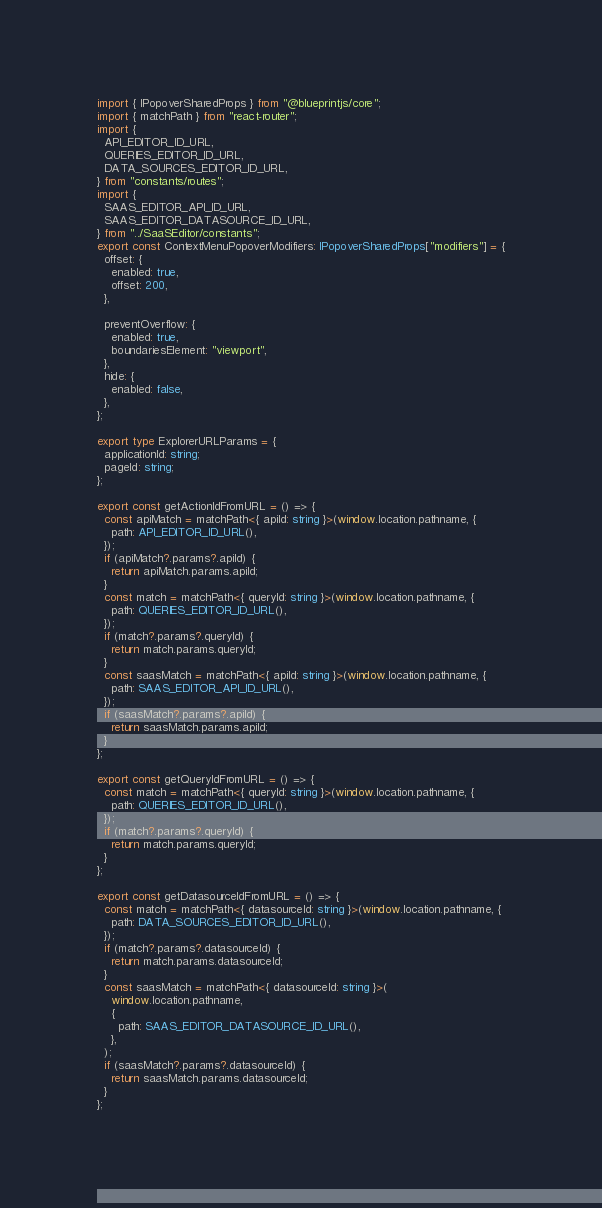Convert code to text. <code><loc_0><loc_0><loc_500><loc_500><_TypeScript_>import { IPopoverSharedProps } from "@blueprintjs/core";
import { matchPath } from "react-router";
import {
  API_EDITOR_ID_URL,
  QUERIES_EDITOR_ID_URL,
  DATA_SOURCES_EDITOR_ID_URL,
} from "constants/routes";
import {
  SAAS_EDITOR_API_ID_URL,
  SAAS_EDITOR_DATASOURCE_ID_URL,
} from "../SaaSEditor/constants";
export const ContextMenuPopoverModifiers: IPopoverSharedProps["modifiers"] = {
  offset: {
    enabled: true,
    offset: 200,
  },

  preventOverflow: {
    enabled: true,
    boundariesElement: "viewport",
  },
  hide: {
    enabled: false,
  },
};

export type ExplorerURLParams = {
  applicationId: string;
  pageId: string;
};

export const getActionIdFromURL = () => {
  const apiMatch = matchPath<{ apiId: string }>(window.location.pathname, {
    path: API_EDITOR_ID_URL(),
  });
  if (apiMatch?.params?.apiId) {
    return apiMatch.params.apiId;
  }
  const match = matchPath<{ queryId: string }>(window.location.pathname, {
    path: QUERIES_EDITOR_ID_URL(),
  });
  if (match?.params?.queryId) {
    return match.params.queryId;
  }
  const saasMatch = matchPath<{ apiId: string }>(window.location.pathname, {
    path: SAAS_EDITOR_API_ID_URL(),
  });
  if (saasMatch?.params?.apiId) {
    return saasMatch.params.apiId;
  }
};

export const getQueryIdFromURL = () => {
  const match = matchPath<{ queryId: string }>(window.location.pathname, {
    path: QUERIES_EDITOR_ID_URL(),
  });
  if (match?.params?.queryId) {
    return match.params.queryId;
  }
};

export const getDatasourceIdFromURL = () => {
  const match = matchPath<{ datasourceId: string }>(window.location.pathname, {
    path: DATA_SOURCES_EDITOR_ID_URL(),
  });
  if (match?.params?.datasourceId) {
    return match.params.datasourceId;
  }
  const saasMatch = matchPath<{ datasourceId: string }>(
    window.location.pathname,
    {
      path: SAAS_EDITOR_DATASOURCE_ID_URL(),
    },
  );
  if (saasMatch?.params?.datasourceId) {
    return saasMatch.params.datasourceId;
  }
};
</code> 